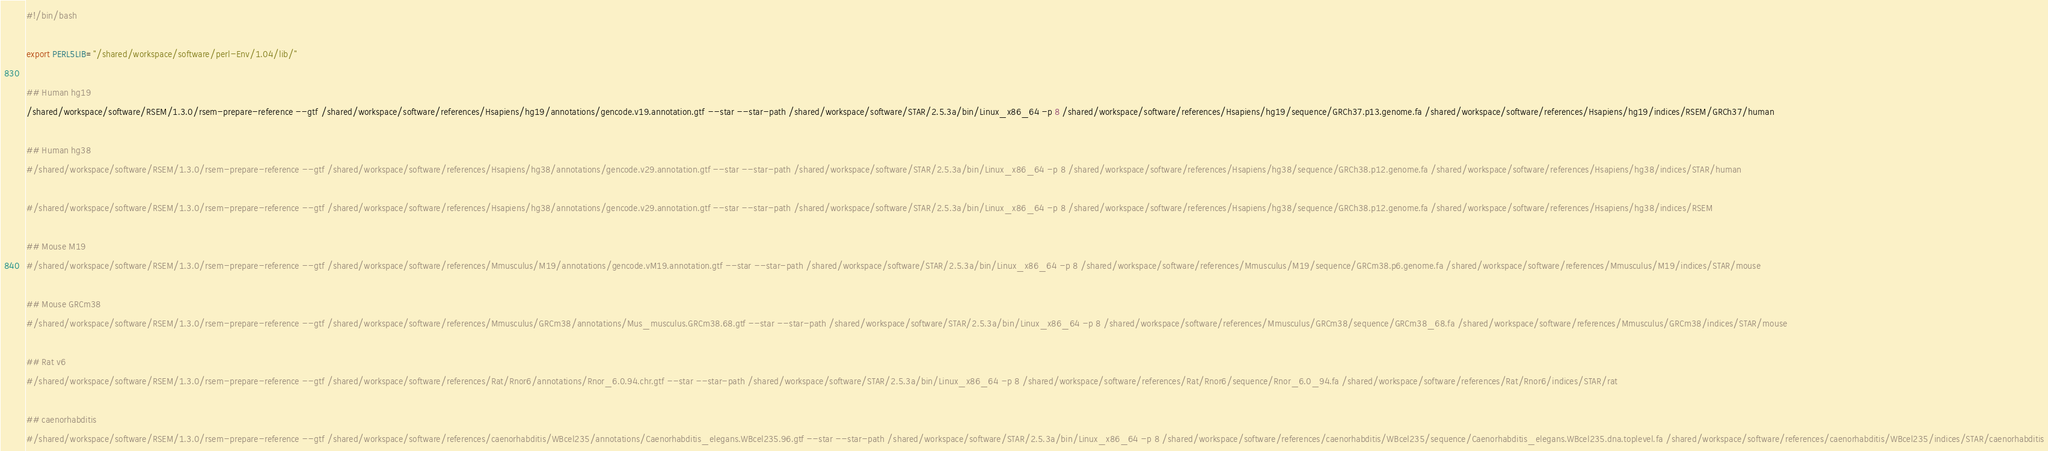<code> <loc_0><loc_0><loc_500><loc_500><_Bash_>#!/bin/bash

export PERL5LIB="/shared/workspace/software/perl-Env/1.04/lib/"

## Human hg19
/shared/workspace/software/RSEM/1.3.0/rsem-prepare-reference --gtf /shared/workspace/software/references/Hsapiens/hg19/annotations/gencode.v19.annotation.gtf --star --star-path /shared/workspace/software/STAR/2.5.3a/bin/Linux_x86_64 -p 8 /shared/workspace/software/references/Hsapiens/hg19/sequence/GRCh37.p13.genome.fa /shared/workspace/software/references/Hsapiens/hg19/indices/RSEM/GRCh37/human

## Human hg38
#/shared/workspace/software/RSEM/1.3.0/rsem-prepare-reference --gtf /shared/workspace/software/references/Hsapiens/hg38/annotations/gencode.v29.annotation.gtf --star --star-path /shared/workspace/software/STAR/2.5.3a/bin/Linux_x86_64 -p 8 /shared/workspace/software/references/Hsapiens/hg38/sequence/GRCh38.p12.genome.fa /shared/workspace/software/references/Hsapiens/hg38/indices/STAR/human

#/shared/workspace/software/RSEM/1.3.0/rsem-prepare-reference --gtf /shared/workspace/software/references/Hsapiens/hg38/annotations/gencode.v29.annotation.gtf --star --star-path /shared/workspace/software/STAR/2.5.3a/bin/Linux_x86_64 -p 8 /shared/workspace/software/references/Hsapiens/hg38/sequence/GRCh38.p12.genome.fa /shared/workspace/software/references/Hsapiens/hg38/indices/RSEM

## Mouse M19
#/shared/workspace/software/RSEM/1.3.0/rsem-prepare-reference --gtf /shared/workspace/software/references/Mmusculus/M19/annotations/gencode.vM19.annotation.gtf --star --star-path /shared/workspace/software/STAR/2.5.3a/bin/Linux_x86_64 -p 8 /shared/workspace/software/references/Mmusculus/M19/sequence/GRCm38.p6.genome.fa /shared/workspace/software/references/Mmusculus/M19/indices/STAR/mouse

## Mouse GRCm38
#/shared/workspace/software/RSEM/1.3.0/rsem-prepare-reference --gtf /shared/workspace/software/references/Mmusculus/GRCm38/annotations/Mus_musculus.GRCm38.68.gtf --star --star-path /shared/workspace/software/STAR/2.5.3a/bin/Linux_x86_64 -p 8 /shared/workspace/software/references/Mmusculus/GRCm38/sequence/GRCm38_68.fa /shared/workspace/software/references/Mmusculus/GRCm38/indices/STAR/mouse

## Rat v6
#/shared/workspace/software/RSEM/1.3.0/rsem-prepare-reference --gtf /shared/workspace/software/references/Rat/Rnor6/annotations/Rnor_6.0.94.chr.gtf --star --star-path /shared/workspace/software/STAR/2.5.3a/bin/Linux_x86_64 -p 8 /shared/workspace/software/references/Rat/Rnor6/sequence/Rnor_6.0_94.fa /shared/workspace/software/references/Rat/Rnor6/indices/STAR/rat

## caenorhabditis
#/shared/workspace/software/RSEM/1.3.0/rsem-prepare-reference --gtf /shared/workspace/software/references/caenorhabditis/WBcel235/annotations/Caenorhabditis_elegans.WBcel235.96.gtf --star --star-path /shared/workspace/software/STAR/2.5.3a/bin/Linux_x86_64 -p 8 /shared/workspace/software/references/caenorhabditis/WBcel235/sequence/Caenorhabditis_elegans.WBcel235.dna.toplevel.fa /shared/workspace/software/references/caenorhabditis/WBcel235/indices/STAR/caenorhabditis
</code> 